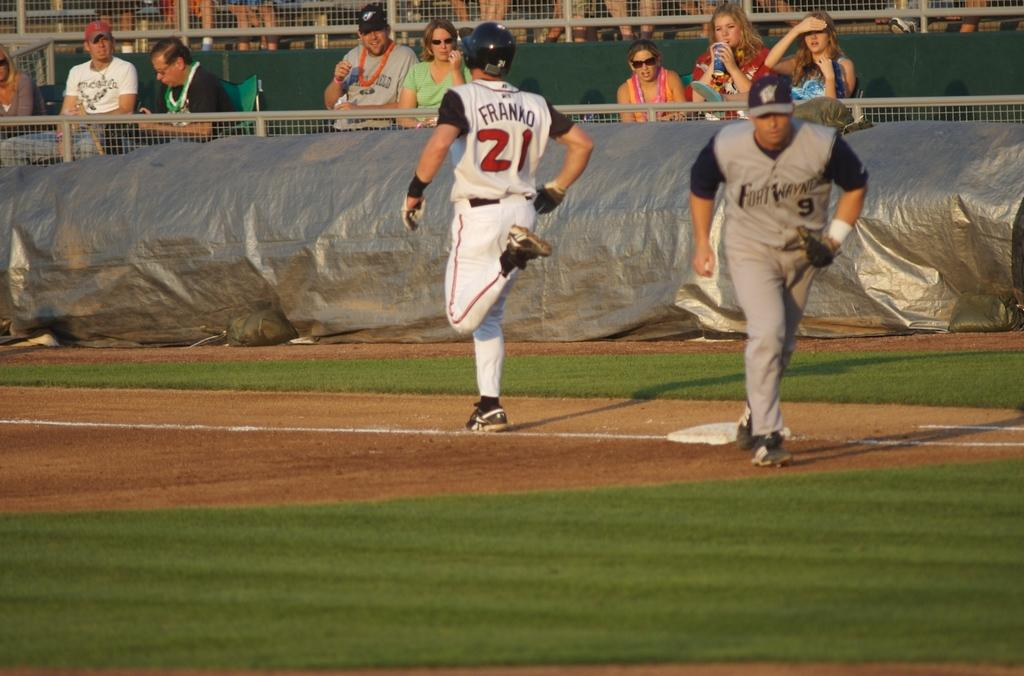<image>
Write a terse but informative summary of the picture. a yellow and blue uniformed baseball player with the number 21 on his uniform is running from a base. 